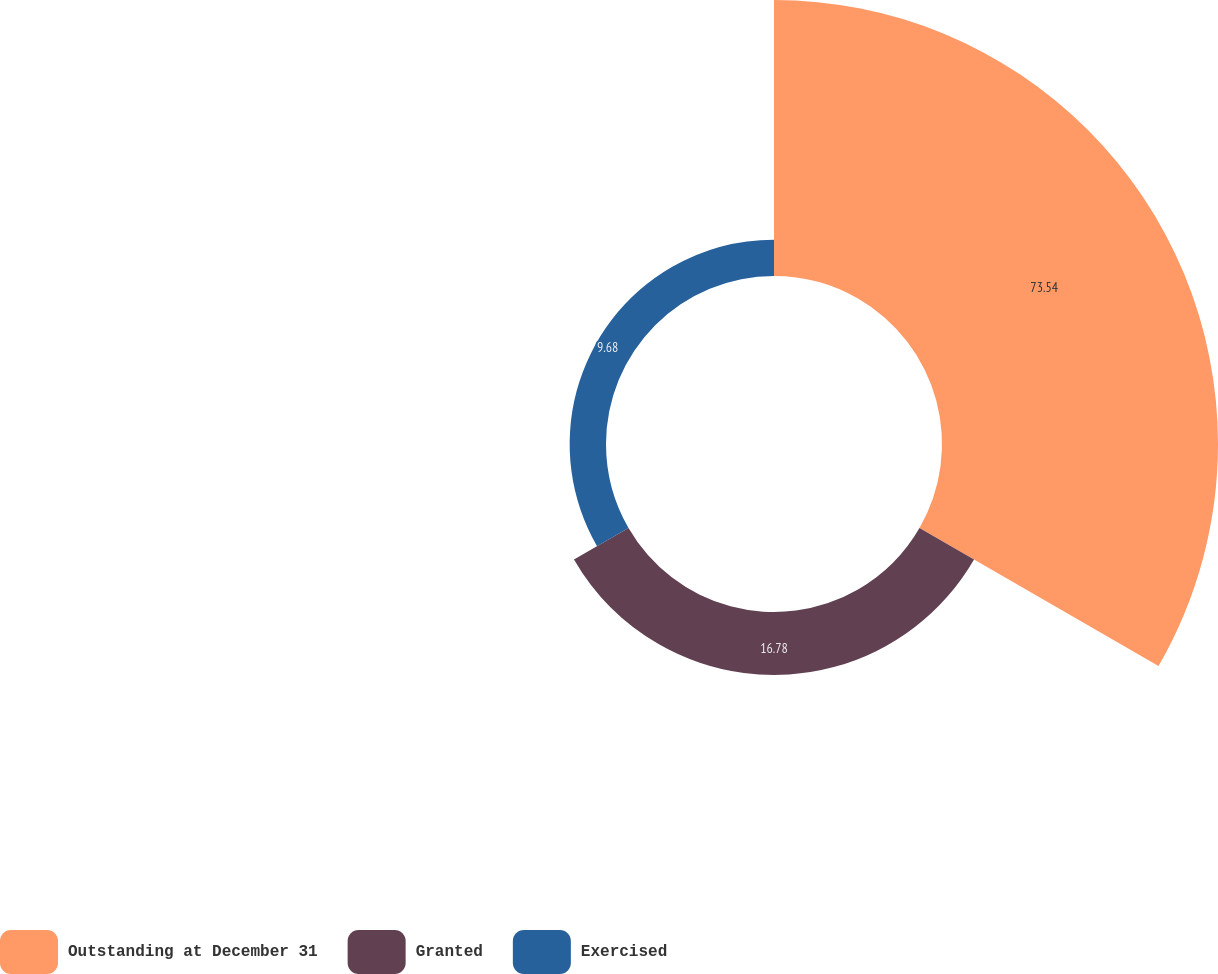Convert chart. <chart><loc_0><loc_0><loc_500><loc_500><pie_chart><fcel>Outstanding at December 31<fcel>Granted<fcel>Exercised<nl><fcel>73.53%<fcel>16.78%<fcel>9.68%<nl></chart> 